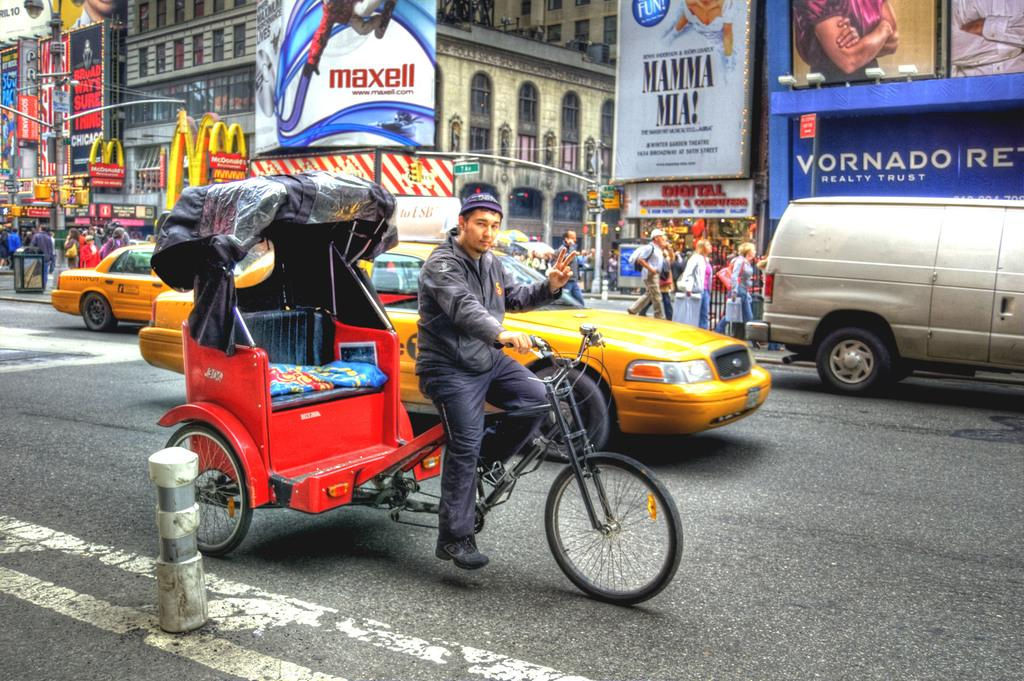<image>
Create a compact narrative representing the image presented. a vornado sign that is next to the street 